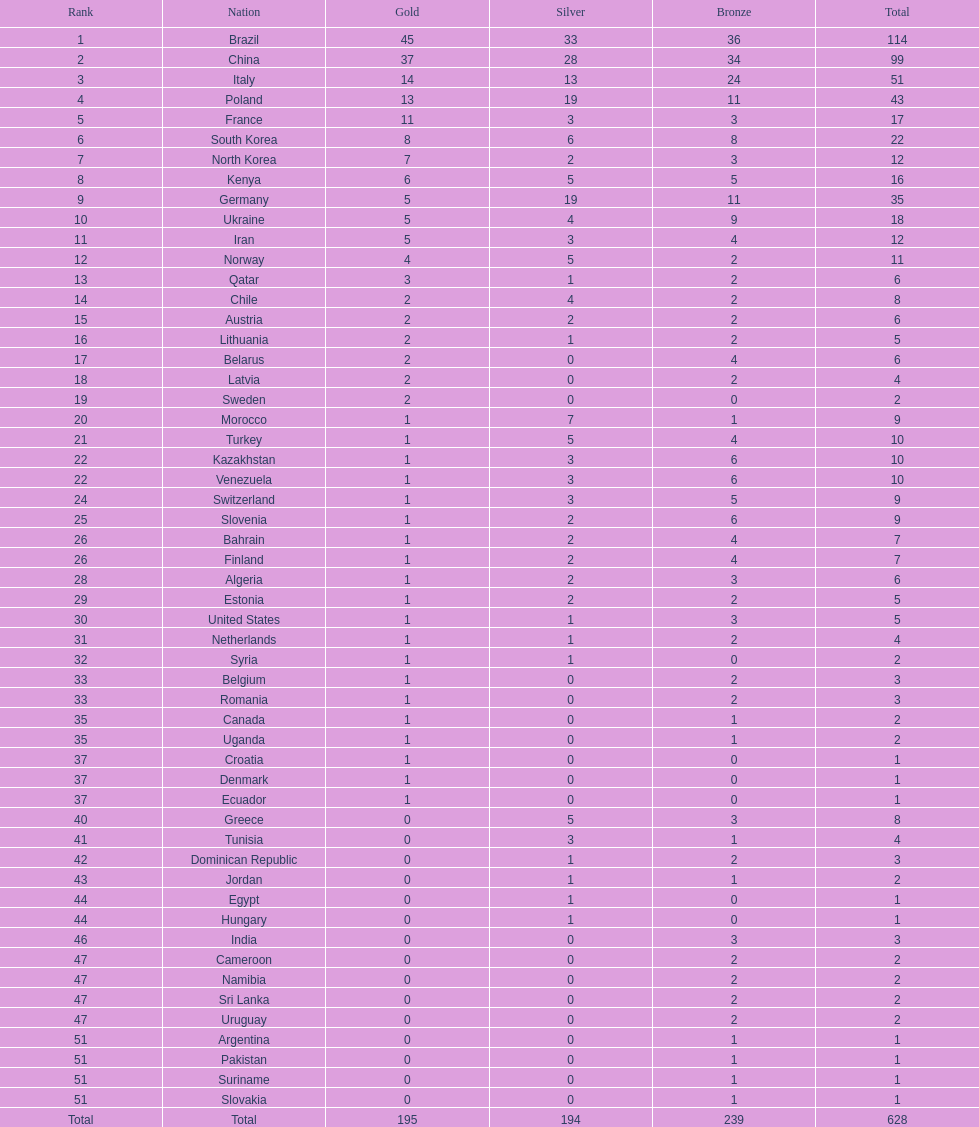How many gold medals did germany earn? 5. Can you give me this table as a dict? {'header': ['Rank', 'Nation', 'Gold', 'Silver', 'Bronze', 'Total'], 'rows': [['1', 'Brazil', '45', '33', '36', '114'], ['2', 'China', '37', '28', '34', '99'], ['3', 'Italy', '14', '13', '24', '51'], ['4', 'Poland', '13', '19', '11', '43'], ['5', 'France', '11', '3', '3', '17'], ['6', 'South Korea', '8', '6', '8', '22'], ['7', 'North Korea', '7', '2', '3', '12'], ['8', 'Kenya', '6', '5', '5', '16'], ['9', 'Germany', '5', '19', '11', '35'], ['10', 'Ukraine', '5', '4', '9', '18'], ['11', 'Iran', '5', '3', '4', '12'], ['12', 'Norway', '4', '5', '2', '11'], ['13', 'Qatar', '3', '1', '2', '6'], ['14', 'Chile', '2', '4', '2', '8'], ['15', 'Austria', '2', '2', '2', '6'], ['16', 'Lithuania', '2', '1', '2', '5'], ['17', 'Belarus', '2', '0', '4', '6'], ['18', 'Latvia', '2', '0', '2', '4'], ['19', 'Sweden', '2', '0', '0', '2'], ['20', 'Morocco', '1', '7', '1', '9'], ['21', 'Turkey', '1', '5', '4', '10'], ['22', 'Kazakhstan', '1', '3', '6', '10'], ['22', 'Venezuela', '1', '3', '6', '10'], ['24', 'Switzerland', '1', '3', '5', '9'], ['25', 'Slovenia', '1', '2', '6', '9'], ['26', 'Bahrain', '1', '2', '4', '7'], ['26', 'Finland', '1', '2', '4', '7'], ['28', 'Algeria', '1', '2', '3', '6'], ['29', 'Estonia', '1', '2', '2', '5'], ['30', 'United States', '1', '1', '3', '5'], ['31', 'Netherlands', '1', '1', '2', '4'], ['32', 'Syria', '1', '1', '0', '2'], ['33', 'Belgium', '1', '0', '2', '3'], ['33', 'Romania', '1', '0', '2', '3'], ['35', 'Canada', '1', '0', '1', '2'], ['35', 'Uganda', '1', '0', '1', '2'], ['37', 'Croatia', '1', '0', '0', '1'], ['37', 'Denmark', '1', '0', '0', '1'], ['37', 'Ecuador', '1', '0', '0', '1'], ['40', 'Greece', '0', '5', '3', '8'], ['41', 'Tunisia', '0', '3', '1', '4'], ['42', 'Dominican Republic', '0', '1', '2', '3'], ['43', 'Jordan', '0', '1', '1', '2'], ['44', 'Egypt', '0', '1', '0', '1'], ['44', 'Hungary', '0', '1', '0', '1'], ['46', 'India', '0', '0', '3', '3'], ['47', 'Cameroon', '0', '0', '2', '2'], ['47', 'Namibia', '0', '0', '2', '2'], ['47', 'Sri Lanka', '0', '0', '2', '2'], ['47', 'Uruguay', '0', '0', '2', '2'], ['51', 'Argentina', '0', '0', '1', '1'], ['51', 'Pakistan', '0', '0', '1', '1'], ['51', 'Suriname', '0', '0', '1', '1'], ['51', 'Slovakia', '0', '0', '1', '1'], ['Total', 'Total', '195', '194', '239', '628']]} 